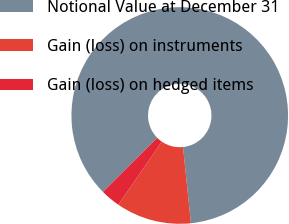<chart> <loc_0><loc_0><loc_500><loc_500><pie_chart><fcel>Notional Value at December 31<fcel>Gain (loss) on instruments<fcel>Gain (loss) on hedged items<nl><fcel>85.81%<fcel>11.24%<fcel>2.95%<nl></chart> 